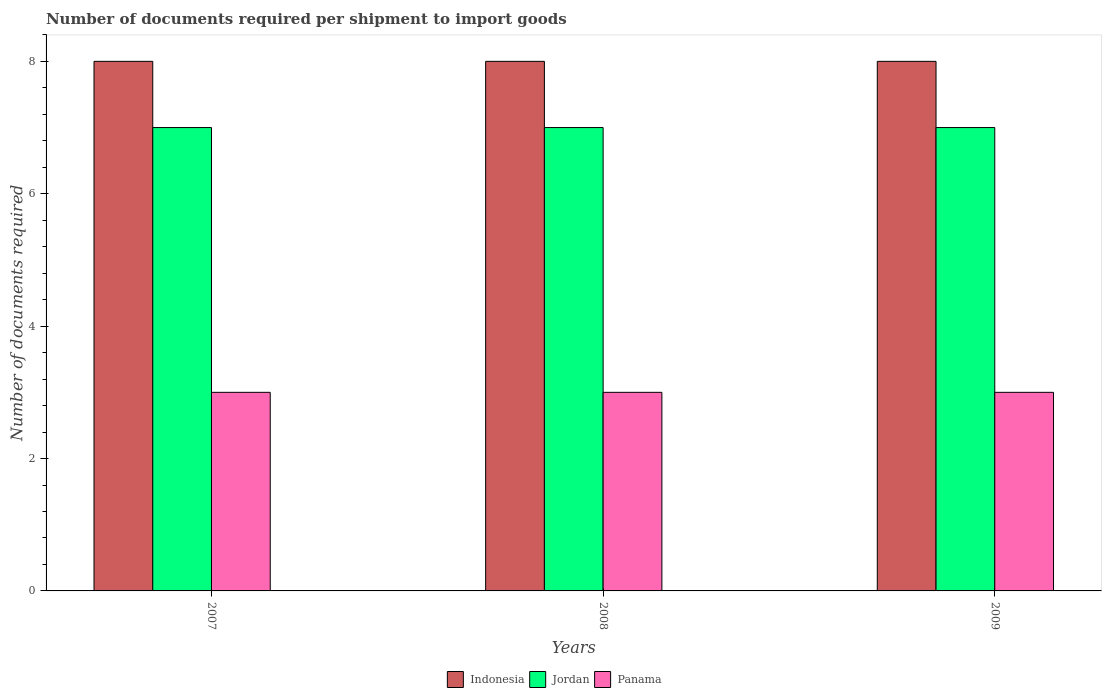How many different coloured bars are there?
Offer a terse response. 3. How many groups of bars are there?
Provide a short and direct response. 3. Are the number of bars per tick equal to the number of legend labels?
Offer a very short reply. Yes. Are the number of bars on each tick of the X-axis equal?
Ensure brevity in your answer.  Yes. In how many cases, is the number of bars for a given year not equal to the number of legend labels?
Ensure brevity in your answer.  0. What is the number of documents required per shipment to import goods in Indonesia in 2008?
Offer a terse response. 8. Across all years, what is the maximum number of documents required per shipment to import goods in Indonesia?
Ensure brevity in your answer.  8. Across all years, what is the minimum number of documents required per shipment to import goods in Panama?
Your answer should be very brief. 3. What is the total number of documents required per shipment to import goods in Jordan in the graph?
Offer a very short reply. 21. What is the difference between the number of documents required per shipment to import goods in Indonesia in 2008 and that in 2009?
Your answer should be very brief. 0. What is the difference between the number of documents required per shipment to import goods in Indonesia in 2007 and the number of documents required per shipment to import goods in Panama in 2008?
Your answer should be very brief. 5. In the year 2007, what is the difference between the number of documents required per shipment to import goods in Jordan and number of documents required per shipment to import goods in Indonesia?
Provide a succinct answer. -1. What is the ratio of the number of documents required per shipment to import goods in Indonesia in 2007 to that in 2009?
Make the answer very short. 1. Is the number of documents required per shipment to import goods in Jordan in 2007 less than that in 2008?
Your answer should be compact. No. Is the difference between the number of documents required per shipment to import goods in Jordan in 2007 and 2009 greater than the difference between the number of documents required per shipment to import goods in Indonesia in 2007 and 2009?
Give a very brief answer. No. What is the difference between the highest and the second highest number of documents required per shipment to import goods in Jordan?
Keep it short and to the point. 0. Is the sum of the number of documents required per shipment to import goods in Indonesia in 2007 and 2008 greater than the maximum number of documents required per shipment to import goods in Panama across all years?
Offer a very short reply. Yes. What does the 2nd bar from the right in 2007 represents?
Ensure brevity in your answer.  Jordan. Is it the case that in every year, the sum of the number of documents required per shipment to import goods in Panama and number of documents required per shipment to import goods in Jordan is greater than the number of documents required per shipment to import goods in Indonesia?
Offer a very short reply. Yes. How many bars are there?
Ensure brevity in your answer.  9. How many years are there in the graph?
Ensure brevity in your answer.  3. What is the difference between two consecutive major ticks on the Y-axis?
Make the answer very short. 2. Are the values on the major ticks of Y-axis written in scientific E-notation?
Give a very brief answer. No. Does the graph contain any zero values?
Ensure brevity in your answer.  No. Does the graph contain grids?
Provide a succinct answer. No. Where does the legend appear in the graph?
Make the answer very short. Bottom center. How are the legend labels stacked?
Your response must be concise. Horizontal. What is the title of the graph?
Ensure brevity in your answer.  Number of documents required per shipment to import goods. Does "Macao" appear as one of the legend labels in the graph?
Your answer should be compact. No. What is the label or title of the X-axis?
Ensure brevity in your answer.  Years. What is the label or title of the Y-axis?
Provide a short and direct response. Number of documents required. What is the Number of documents required in Panama in 2007?
Offer a very short reply. 3. What is the Number of documents required in Jordan in 2008?
Provide a succinct answer. 7. What is the Number of documents required of Panama in 2008?
Your answer should be very brief. 3. What is the Number of documents required in Jordan in 2009?
Offer a terse response. 7. Across all years, what is the maximum Number of documents required of Jordan?
Offer a terse response. 7. Across all years, what is the maximum Number of documents required in Panama?
Your answer should be compact. 3. Across all years, what is the minimum Number of documents required in Panama?
Ensure brevity in your answer.  3. What is the total Number of documents required of Indonesia in the graph?
Make the answer very short. 24. What is the total Number of documents required in Jordan in the graph?
Offer a terse response. 21. What is the difference between the Number of documents required in Panama in 2007 and that in 2008?
Your answer should be very brief. 0. What is the difference between the Number of documents required in Indonesia in 2007 and that in 2009?
Provide a succinct answer. 0. What is the difference between the Number of documents required in Panama in 2007 and that in 2009?
Your response must be concise. 0. What is the difference between the Number of documents required of Jordan in 2008 and that in 2009?
Provide a short and direct response. 0. What is the difference between the Number of documents required of Indonesia in 2007 and the Number of documents required of Jordan in 2008?
Provide a short and direct response. 1. What is the difference between the Number of documents required in Indonesia in 2007 and the Number of documents required in Panama in 2008?
Give a very brief answer. 5. What is the difference between the Number of documents required in Jordan in 2007 and the Number of documents required in Panama in 2009?
Make the answer very short. 4. What is the difference between the Number of documents required in Indonesia in 2008 and the Number of documents required in Jordan in 2009?
Ensure brevity in your answer.  1. What is the difference between the Number of documents required of Indonesia in 2008 and the Number of documents required of Panama in 2009?
Your answer should be compact. 5. What is the difference between the Number of documents required in Jordan in 2008 and the Number of documents required in Panama in 2009?
Provide a short and direct response. 4. What is the average Number of documents required of Jordan per year?
Your answer should be compact. 7. What is the average Number of documents required in Panama per year?
Keep it short and to the point. 3. In the year 2007, what is the difference between the Number of documents required in Indonesia and Number of documents required in Jordan?
Make the answer very short. 1. In the year 2008, what is the difference between the Number of documents required of Indonesia and Number of documents required of Jordan?
Give a very brief answer. 1. In the year 2008, what is the difference between the Number of documents required in Jordan and Number of documents required in Panama?
Your answer should be compact. 4. In the year 2009, what is the difference between the Number of documents required in Indonesia and Number of documents required in Jordan?
Your response must be concise. 1. In the year 2009, what is the difference between the Number of documents required of Jordan and Number of documents required of Panama?
Offer a terse response. 4. What is the ratio of the Number of documents required in Indonesia in 2007 to that in 2008?
Your answer should be very brief. 1. What is the ratio of the Number of documents required of Jordan in 2007 to that in 2008?
Keep it short and to the point. 1. What is the ratio of the Number of documents required in Panama in 2007 to that in 2008?
Make the answer very short. 1. What is the ratio of the Number of documents required of Jordan in 2007 to that in 2009?
Your response must be concise. 1. What is the ratio of the Number of documents required of Panama in 2007 to that in 2009?
Provide a short and direct response. 1. What is the ratio of the Number of documents required in Jordan in 2008 to that in 2009?
Your answer should be compact. 1. What is the difference between the highest and the lowest Number of documents required of Indonesia?
Ensure brevity in your answer.  0. What is the difference between the highest and the lowest Number of documents required in Jordan?
Provide a short and direct response. 0. 